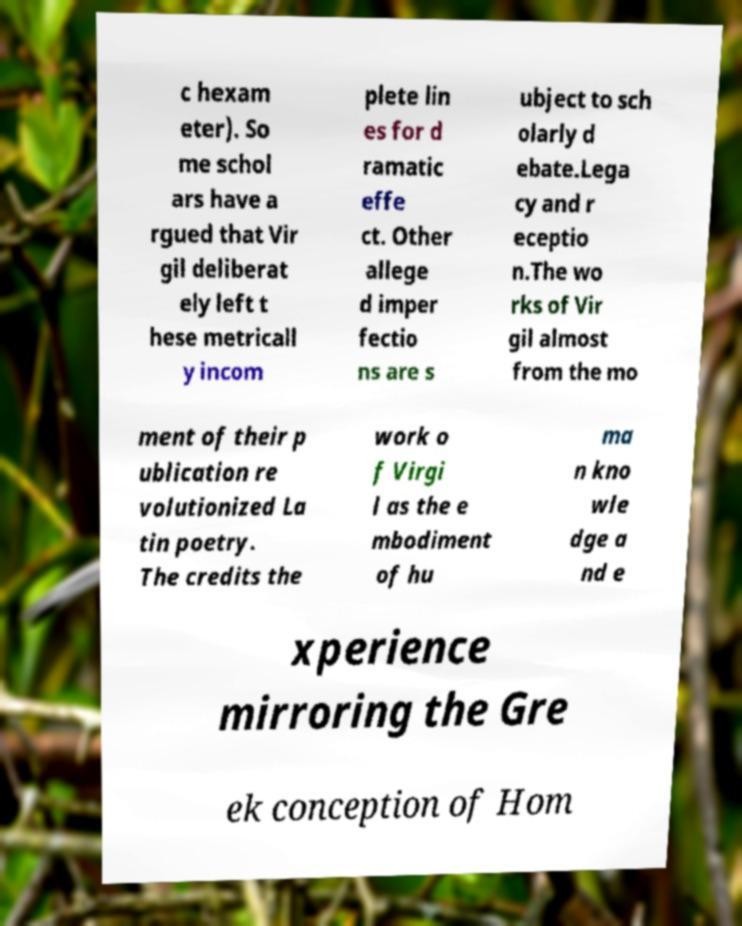Could you extract and type out the text from this image? c hexam eter). So me schol ars have a rgued that Vir gil deliberat ely left t hese metricall y incom plete lin es for d ramatic effe ct. Other allege d imper fectio ns are s ubject to sch olarly d ebate.Lega cy and r eceptio n.The wo rks of Vir gil almost from the mo ment of their p ublication re volutionized La tin poetry. The credits the work o f Virgi l as the e mbodiment of hu ma n kno wle dge a nd e xperience mirroring the Gre ek conception of Hom 